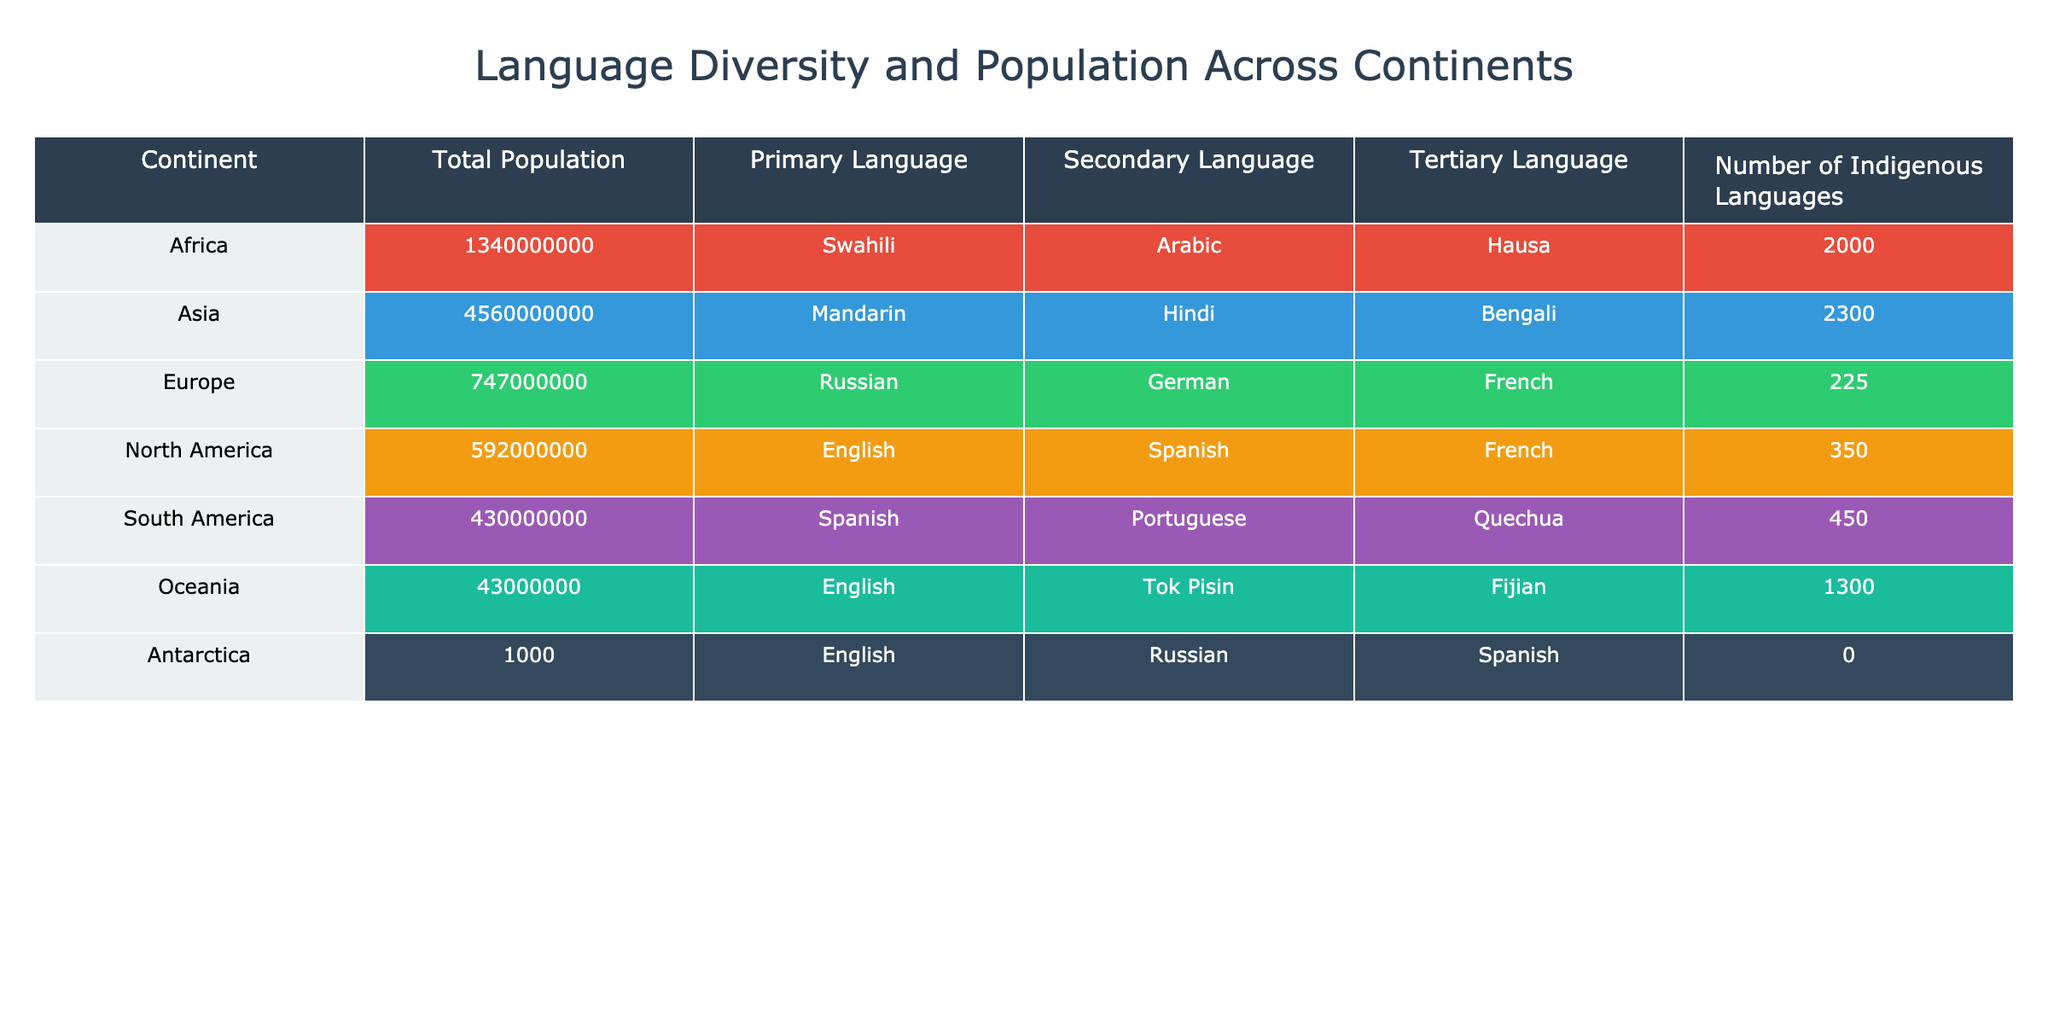What is the total population of Asia? The table lists Asia's total population as 4,560,000,000.
Answer: 4,560,000,000 Which continent has the highest number of indigenous languages? The table shows Africa with 2,000 indigenous languages, which is the highest among the continents.
Answer: Africa True or False: Europe has more secondary languages than North America. Europe has German and French as secondary languages (2 total), while North America has Spanish and French (2 total). Therefore, the statement is False.
Answer: False What is the difference in total population between Africa and South America? Africa's total population is 1,340,000,000 and South America's is 430,000,000. The difference is 1,340,000,000 - 430,000,000 = 910,000,000.
Answer: 910,000,000 Which primary language is spoken in Oceania? The table indicates that the primary language in Oceania is English.
Answer: English How many more indigenous languages does Asia have compared to Europe? Asia has 2,300 indigenous languages while Europe has 225. The difference is 2,300 - 225 = 2,075.
Answer: 2,075 Which continent has Spanish as a tertiary language? South America and North America both list Spanish as a tertiary language in the table.
Answer: South America and North America If you combine the total populations of North America and Oceania, what do you get? North America's total population is 592,000,000 and Oceania's is 43,000,000. Adding them gives 592,000,000 + 43,000,000 = 635,000,000.
Answer: 635,000,000 Which continent has the least total population? The table shows Antarctica with a total population of only 1,000, which is the least among all continents.
Answer: Antarctica Is Arabic a primary language in any continent listed? The table shows that Arabic is listed as a secondary language in Africa, but not as a primary language for any continent. Therefore, the answer is no.
Answer: No What is the sum of the total populations of Africa and Europe? Africa's total population is 1,340,000,000 and Europe's is 747,000,000. The sum is 1,340,000,000 + 747,000,000 = 2,087,000,000.
Answer: 2,087,000,000 